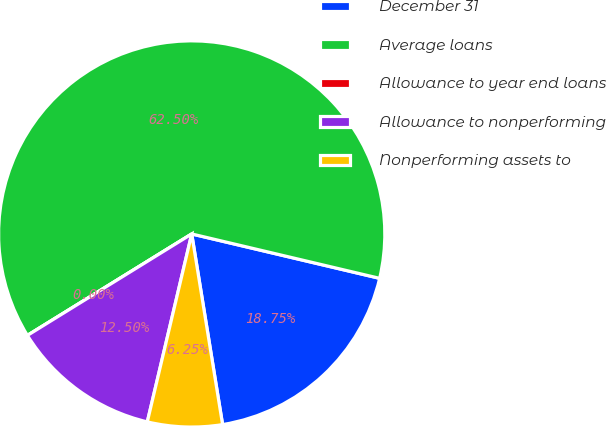Convert chart to OTSL. <chart><loc_0><loc_0><loc_500><loc_500><pie_chart><fcel>December 31<fcel>Average loans<fcel>Allowance to year end loans<fcel>Allowance to nonperforming<fcel>Nonperforming assets to<nl><fcel>18.75%<fcel>62.49%<fcel>0.0%<fcel>12.5%<fcel>6.25%<nl></chart> 